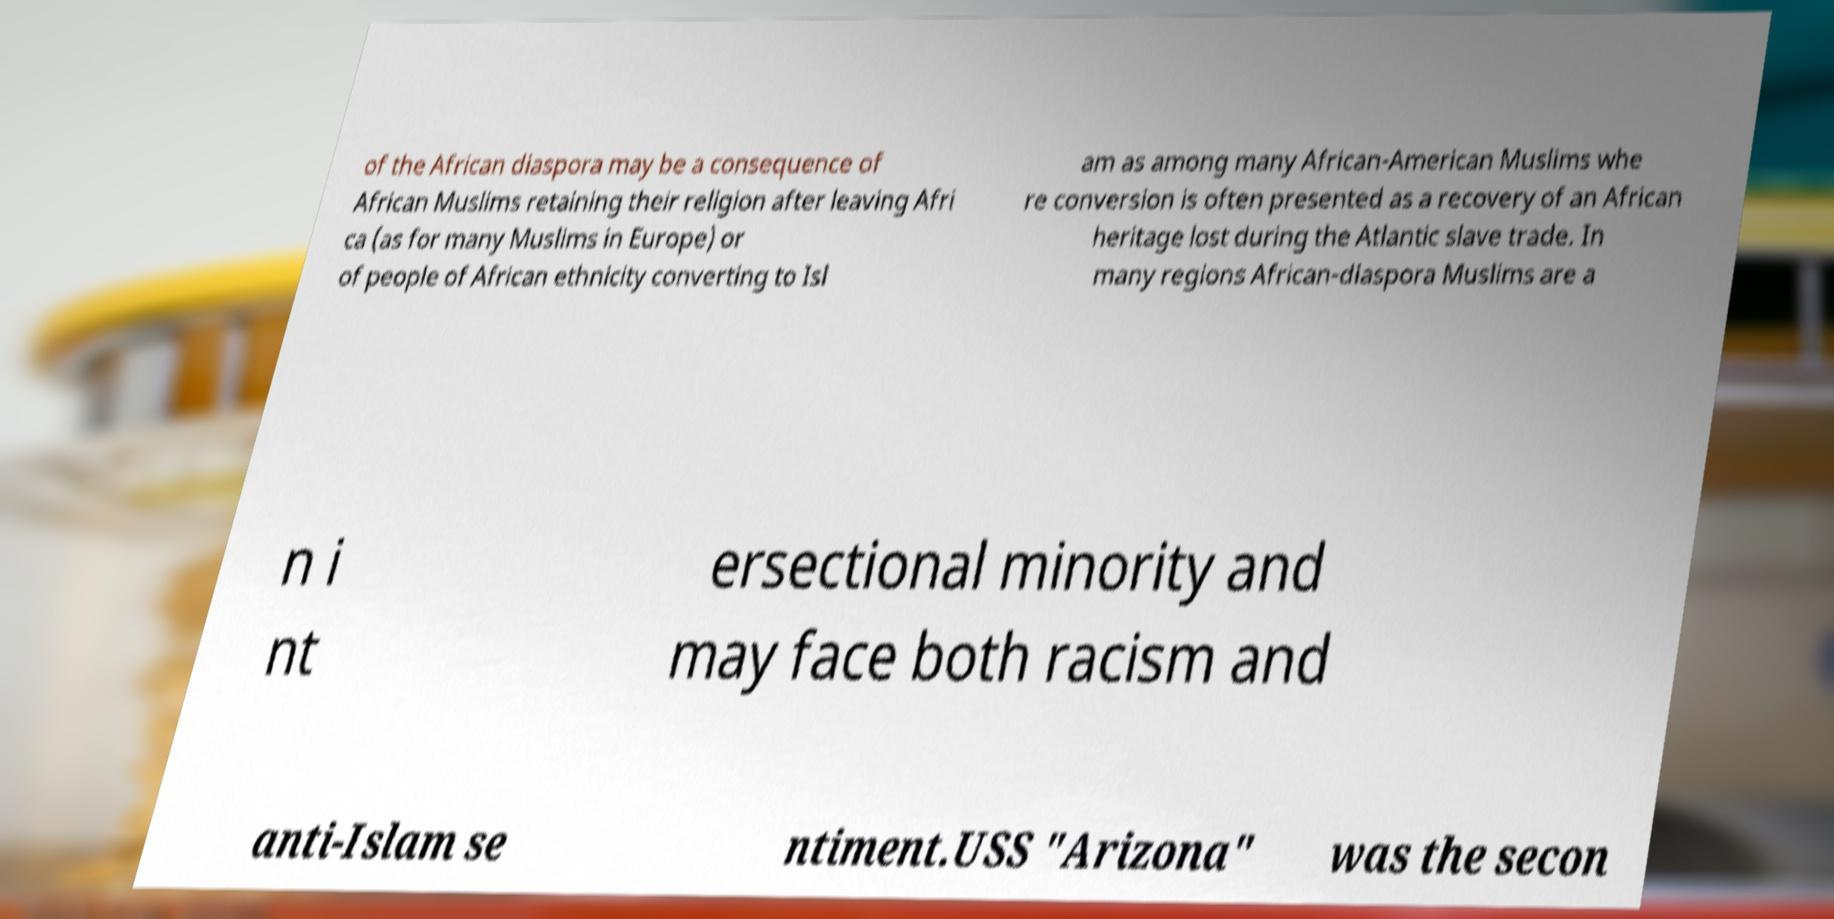Please read and relay the text visible in this image. What does it say? of the African diaspora may be a consequence of African Muslims retaining their religion after leaving Afri ca (as for many Muslims in Europe) or of people of African ethnicity converting to Isl am as among many African-American Muslims whe re conversion is often presented as a recovery of an African heritage lost during the Atlantic slave trade. In many regions African-diaspora Muslims are a n i nt ersectional minority and may face both racism and anti-Islam se ntiment.USS "Arizona" was the secon 